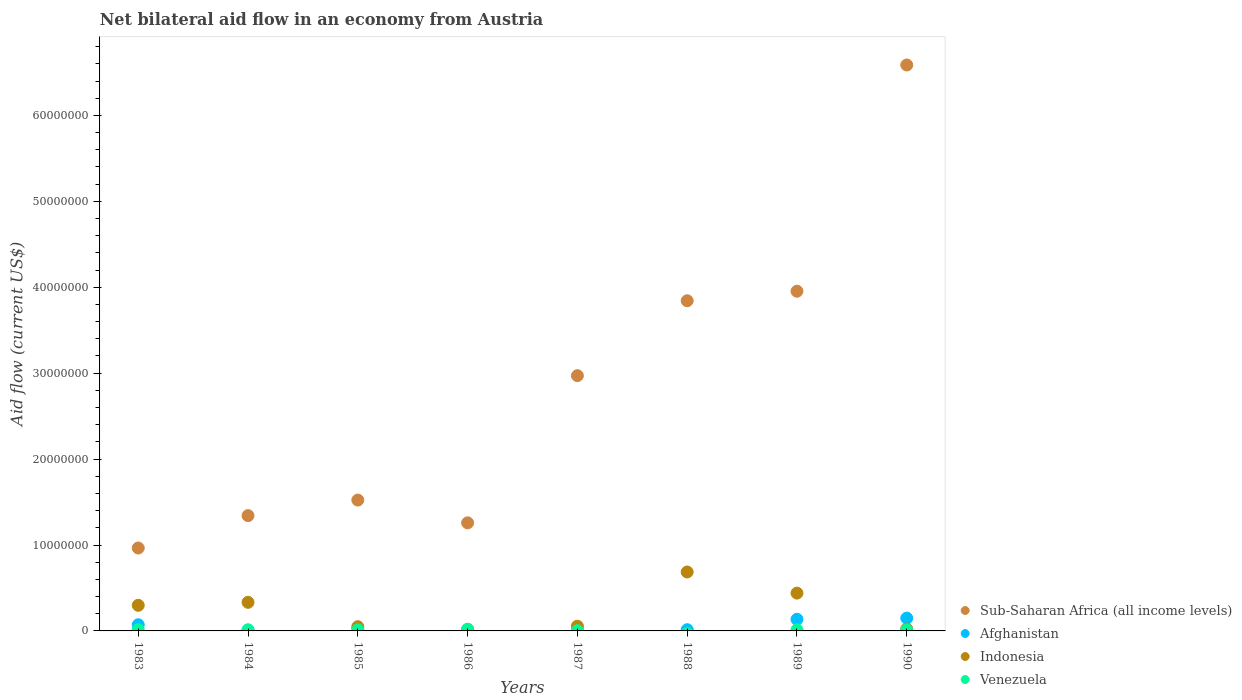How many different coloured dotlines are there?
Provide a succinct answer. 4. Across all years, what is the maximum net bilateral aid flow in Afghanistan?
Keep it short and to the point. 1.49e+06. Across all years, what is the minimum net bilateral aid flow in Sub-Saharan Africa (all income levels)?
Offer a very short reply. 9.65e+06. What is the total net bilateral aid flow in Venezuela in the graph?
Ensure brevity in your answer.  8.30e+05. What is the difference between the net bilateral aid flow in Indonesia in 1983 and that in 1987?
Give a very brief answer. 2.43e+06. What is the difference between the net bilateral aid flow in Afghanistan in 1984 and the net bilateral aid flow in Sub-Saharan Africa (all income levels) in 1983?
Offer a very short reply. -9.54e+06. What is the average net bilateral aid flow in Sub-Saharan Africa (all income levels) per year?
Your response must be concise. 2.81e+07. In the year 1989, what is the difference between the net bilateral aid flow in Sub-Saharan Africa (all income levels) and net bilateral aid flow in Venezuela?
Offer a terse response. 3.94e+07. What is the ratio of the net bilateral aid flow in Indonesia in 1986 to that in 1990?
Offer a very short reply. 0.83. What is the difference between the highest and the second highest net bilateral aid flow in Venezuela?
Your answer should be very brief. 2.00e+04. What is the difference between the highest and the lowest net bilateral aid flow in Afghanistan?
Give a very brief answer. 1.40e+06. In how many years, is the net bilateral aid flow in Venezuela greater than the average net bilateral aid flow in Venezuela taken over all years?
Your answer should be very brief. 6. Is the sum of the net bilateral aid flow in Venezuela in 1983 and 1987 greater than the maximum net bilateral aid flow in Indonesia across all years?
Make the answer very short. No. Is it the case that in every year, the sum of the net bilateral aid flow in Afghanistan and net bilateral aid flow in Indonesia  is greater than the sum of net bilateral aid flow in Sub-Saharan Africa (all income levels) and net bilateral aid flow in Venezuela?
Your answer should be very brief. Yes. Does the net bilateral aid flow in Afghanistan monotonically increase over the years?
Provide a succinct answer. No. Is the net bilateral aid flow in Afghanistan strictly greater than the net bilateral aid flow in Venezuela over the years?
Give a very brief answer. No. How many dotlines are there?
Offer a very short reply. 4. How many years are there in the graph?
Keep it short and to the point. 8. Are the values on the major ticks of Y-axis written in scientific E-notation?
Provide a succinct answer. No. Does the graph contain any zero values?
Provide a succinct answer. Yes. Does the graph contain grids?
Provide a short and direct response. No. How are the legend labels stacked?
Offer a very short reply. Vertical. What is the title of the graph?
Provide a short and direct response. Net bilateral aid flow in an economy from Austria. What is the label or title of the X-axis?
Make the answer very short. Years. What is the label or title of the Y-axis?
Provide a short and direct response. Aid flow (current US$). What is the Aid flow (current US$) of Sub-Saharan Africa (all income levels) in 1983?
Ensure brevity in your answer.  9.65e+06. What is the Aid flow (current US$) in Afghanistan in 1983?
Make the answer very short. 7.20e+05. What is the Aid flow (current US$) of Indonesia in 1983?
Give a very brief answer. 2.98e+06. What is the Aid flow (current US$) of Sub-Saharan Africa (all income levels) in 1984?
Ensure brevity in your answer.  1.34e+07. What is the Aid flow (current US$) in Afghanistan in 1984?
Your answer should be compact. 1.10e+05. What is the Aid flow (current US$) of Indonesia in 1984?
Provide a succinct answer. 3.33e+06. What is the Aid flow (current US$) in Venezuela in 1984?
Give a very brief answer. 1.10e+05. What is the Aid flow (current US$) in Sub-Saharan Africa (all income levels) in 1985?
Make the answer very short. 1.52e+07. What is the Aid flow (current US$) of Afghanistan in 1985?
Your answer should be very brief. 1.70e+05. What is the Aid flow (current US$) of Venezuela in 1985?
Provide a short and direct response. 1.20e+05. What is the Aid flow (current US$) in Sub-Saharan Africa (all income levels) in 1986?
Offer a terse response. 1.26e+07. What is the Aid flow (current US$) in Indonesia in 1986?
Your answer should be compact. 1.90e+05. What is the Aid flow (current US$) in Venezuela in 1986?
Your response must be concise. 1.70e+05. What is the Aid flow (current US$) in Sub-Saharan Africa (all income levels) in 1987?
Provide a short and direct response. 2.97e+07. What is the Aid flow (current US$) in Sub-Saharan Africa (all income levels) in 1988?
Offer a terse response. 3.84e+07. What is the Aid flow (current US$) of Indonesia in 1988?
Provide a succinct answer. 6.86e+06. What is the Aid flow (current US$) in Sub-Saharan Africa (all income levels) in 1989?
Give a very brief answer. 3.95e+07. What is the Aid flow (current US$) of Afghanistan in 1989?
Ensure brevity in your answer.  1.35e+06. What is the Aid flow (current US$) of Indonesia in 1989?
Provide a succinct answer. 4.40e+06. What is the Aid flow (current US$) in Sub-Saharan Africa (all income levels) in 1990?
Your answer should be very brief. 6.59e+07. What is the Aid flow (current US$) of Afghanistan in 1990?
Ensure brevity in your answer.  1.49e+06. What is the Aid flow (current US$) in Indonesia in 1990?
Ensure brevity in your answer.  2.30e+05. What is the Aid flow (current US$) of Venezuela in 1990?
Provide a succinct answer. 1.20e+05. Across all years, what is the maximum Aid flow (current US$) in Sub-Saharan Africa (all income levels)?
Offer a very short reply. 6.59e+07. Across all years, what is the maximum Aid flow (current US$) of Afghanistan?
Your answer should be very brief. 1.49e+06. Across all years, what is the maximum Aid flow (current US$) of Indonesia?
Your answer should be compact. 6.86e+06. Across all years, what is the maximum Aid flow (current US$) of Venezuela?
Give a very brief answer. 1.70e+05. Across all years, what is the minimum Aid flow (current US$) in Sub-Saharan Africa (all income levels)?
Your response must be concise. 9.65e+06. Across all years, what is the minimum Aid flow (current US$) in Afghanistan?
Offer a terse response. 9.00e+04. Across all years, what is the minimum Aid flow (current US$) of Indonesia?
Give a very brief answer. 1.90e+05. Across all years, what is the minimum Aid flow (current US$) of Venezuela?
Provide a succinct answer. 0. What is the total Aid flow (current US$) in Sub-Saharan Africa (all income levels) in the graph?
Keep it short and to the point. 2.24e+08. What is the total Aid flow (current US$) of Afghanistan in the graph?
Your response must be concise. 4.18e+06. What is the total Aid flow (current US$) in Indonesia in the graph?
Offer a very short reply. 1.90e+07. What is the total Aid flow (current US$) of Venezuela in the graph?
Make the answer very short. 8.30e+05. What is the difference between the Aid flow (current US$) in Sub-Saharan Africa (all income levels) in 1983 and that in 1984?
Your answer should be compact. -3.77e+06. What is the difference between the Aid flow (current US$) of Indonesia in 1983 and that in 1984?
Your answer should be compact. -3.50e+05. What is the difference between the Aid flow (current US$) of Venezuela in 1983 and that in 1984?
Offer a terse response. 4.00e+04. What is the difference between the Aid flow (current US$) in Sub-Saharan Africa (all income levels) in 1983 and that in 1985?
Ensure brevity in your answer.  -5.58e+06. What is the difference between the Aid flow (current US$) in Indonesia in 1983 and that in 1985?
Your response must be concise. 2.49e+06. What is the difference between the Aid flow (current US$) in Sub-Saharan Africa (all income levels) in 1983 and that in 1986?
Provide a succinct answer. -2.93e+06. What is the difference between the Aid flow (current US$) of Afghanistan in 1983 and that in 1986?
Keep it short and to the point. 6.30e+05. What is the difference between the Aid flow (current US$) of Indonesia in 1983 and that in 1986?
Your response must be concise. 2.79e+06. What is the difference between the Aid flow (current US$) of Sub-Saharan Africa (all income levels) in 1983 and that in 1987?
Your response must be concise. -2.01e+07. What is the difference between the Aid flow (current US$) of Indonesia in 1983 and that in 1987?
Your answer should be very brief. 2.43e+06. What is the difference between the Aid flow (current US$) in Sub-Saharan Africa (all income levels) in 1983 and that in 1988?
Your answer should be very brief. -2.88e+07. What is the difference between the Aid flow (current US$) in Afghanistan in 1983 and that in 1988?
Offer a terse response. 5.80e+05. What is the difference between the Aid flow (current US$) of Indonesia in 1983 and that in 1988?
Provide a succinct answer. -3.88e+06. What is the difference between the Aid flow (current US$) of Sub-Saharan Africa (all income levels) in 1983 and that in 1989?
Provide a short and direct response. -2.99e+07. What is the difference between the Aid flow (current US$) in Afghanistan in 1983 and that in 1989?
Provide a succinct answer. -6.30e+05. What is the difference between the Aid flow (current US$) of Indonesia in 1983 and that in 1989?
Provide a succinct answer. -1.42e+06. What is the difference between the Aid flow (current US$) in Venezuela in 1983 and that in 1989?
Keep it short and to the point. 2.00e+04. What is the difference between the Aid flow (current US$) in Sub-Saharan Africa (all income levels) in 1983 and that in 1990?
Offer a very short reply. -5.62e+07. What is the difference between the Aid flow (current US$) of Afghanistan in 1983 and that in 1990?
Your response must be concise. -7.70e+05. What is the difference between the Aid flow (current US$) in Indonesia in 1983 and that in 1990?
Offer a terse response. 2.75e+06. What is the difference between the Aid flow (current US$) in Venezuela in 1983 and that in 1990?
Offer a terse response. 3.00e+04. What is the difference between the Aid flow (current US$) in Sub-Saharan Africa (all income levels) in 1984 and that in 1985?
Your response must be concise. -1.81e+06. What is the difference between the Aid flow (current US$) in Indonesia in 1984 and that in 1985?
Provide a short and direct response. 2.84e+06. What is the difference between the Aid flow (current US$) in Sub-Saharan Africa (all income levels) in 1984 and that in 1986?
Offer a terse response. 8.40e+05. What is the difference between the Aid flow (current US$) of Indonesia in 1984 and that in 1986?
Your answer should be very brief. 3.14e+06. What is the difference between the Aid flow (current US$) of Venezuela in 1984 and that in 1986?
Give a very brief answer. -6.00e+04. What is the difference between the Aid flow (current US$) of Sub-Saharan Africa (all income levels) in 1984 and that in 1987?
Offer a very short reply. -1.63e+07. What is the difference between the Aid flow (current US$) of Afghanistan in 1984 and that in 1987?
Offer a terse response. 0. What is the difference between the Aid flow (current US$) in Indonesia in 1984 and that in 1987?
Provide a succinct answer. 2.78e+06. What is the difference between the Aid flow (current US$) in Venezuela in 1984 and that in 1987?
Make the answer very short. 8.00e+04. What is the difference between the Aid flow (current US$) of Sub-Saharan Africa (all income levels) in 1984 and that in 1988?
Your answer should be very brief. -2.50e+07. What is the difference between the Aid flow (current US$) in Afghanistan in 1984 and that in 1988?
Your answer should be compact. -3.00e+04. What is the difference between the Aid flow (current US$) in Indonesia in 1984 and that in 1988?
Make the answer very short. -3.53e+06. What is the difference between the Aid flow (current US$) in Sub-Saharan Africa (all income levels) in 1984 and that in 1989?
Ensure brevity in your answer.  -2.61e+07. What is the difference between the Aid flow (current US$) of Afghanistan in 1984 and that in 1989?
Keep it short and to the point. -1.24e+06. What is the difference between the Aid flow (current US$) of Indonesia in 1984 and that in 1989?
Give a very brief answer. -1.07e+06. What is the difference between the Aid flow (current US$) of Sub-Saharan Africa (all income levels) in 1984 and that in 1990?
Ensure brevity in your answer.  -5.24e+07. What is the difference between the Aid flow (current US$) of Afghanistan in 1984 and that in 1990?
Your answer should be very brief. -1.38e+06. What is the difference between the Aid flow (current US$) of Indonesia in 1984 and that in 1990?
Ensure brevity in your answer.  3.10e+06. What is the difference between the Aid flow (current US$) of Venezuela in 1984 and that in 1990?
Give a very brief answer. -10000. What is the difference between the Aid flow (current US$) in Sub-Saharan Africa (all income levels) in 1985 and that in 1986?
Provide a succinct answer. 2.65e+06. What is the difference between the Aid flow (current US$) in Afghanistan in 1985 and that in 1986?
Make the answer very short. 8.00e+04. What is the difference between the Aid flow (current US$) in Indonesia in 1985 and that in 1986?
Provide a short and direct response. 3.00e+05. What is the difference between the Aid flow (current US$) in Venezuela in 1985 and that in 1986?
Your answer should be compact. -5.00e+04. What is the difference between the Aid flow (current US$) of Sub-Saharan Africa (all income levels) in 1985 and that in 1987?
Ensure brevity in your answer.  -1.45e+07. What is the difference between the Aid flow (current US$) in Afghanistan in 1985 and that in 1987?
Provide a short and direct response. 6.00e+04. What is the difference between the Aid flow (current US$) of Indonesia in 1985 and that in 1987?
Keep it short and to the point. -6.00e+04. What is the difference between the Aid flow (current US$) of Venezuela in 1985 and that in 1987?
Make the answer very short. 9.00e+04. What is the difference between the Aid flow (current US$) of Sub-Saharan Africa (all income levels) in 1985 and that in 1988?
Provide a short and direct response. -2.32e+07. What is the difference between the Aid flow (current US$) of Afghanistan in 1985 and that in 1988?
Provide a short and direct response. 3.00e+04. What is the difference between the Aid flow (current US$) in Indonesia in 1985 and that in 1988?
Provide a short and direct response. -6.37e+06. What is the difference between the Aid flow (current US$) of Sub-Saharan Africa (all income levels) in 1985 and that in 1989?
Keep it short and to the point. -2.43e+07. What is the difference between the Aid flow (current US$) of Afghanistan in 1985 and that in 1989?
Your answer should be very brief. -1.18e+06. What is the difference between the Aid flow (current US$) in Indonesia in 1985 and that in 1989?
Give a very brief answer. -3.91e+06. What is the difference between the Aid flow (current US$) in Venezuela in 1985 and that in 1989?
Your answer should be compact. -10000. What is the difference between the Aid flow (current US$) of Sub-Saharan Africa (all income levels) in 1985 and that in 1990?
Ensure brevity in your answer.  -5.06e+07. What is the difference between the Aid flow (current US$) of Afghanistan in 1985 and that in 1990?
Keep it short and to the point. -1.32e+06. What is the difference between the Aid flow (current US$) of Sub-Saharan Africa (all income levels) in 1986 and that in 1987?
Offer a very short reply. -1.71e+07. What is the difference between the Aid flow (current US$) of Afghanistan in 1986 and that in 1987?
Offer a very short reply. -2.00e+04. What is the difference between the Aid flow (current US$) in Indonesia in 1986 and that in 1987?
Your response must be concise. -3.60e+05. What is the difference between the Aid flow (current US$) in Venezuela in 1986 and that in 1987?
Provide a succinct answer. 1.40e+05. What is the difference between the Aid flow (current US$) of Sub-Saharan Africa (all income levels) in 1986 and that in 1988?
Your answer should be very brief. -2.58e+07. What is the difference between the Aid flow (current US$) of Afghanistan in 1986 and that in 1988?
Offer a terse response. -5.00e+04. What is the difference between the Aid flow (current US$) of Indonesia in 1986 and that in 1988?
Provide a succinct answer. -6.67e+06. What is the difference between the Aid flow (current US$) of Sub-Saharan Africa (all income levels) in 1986 and that in 1989?
Provide a succinct answer. -2.70e+07. What is the difference between the Aid flow (current US$) in Afghanistan in 1986 and that in 1989?
Provide a succinct answer. -1.26e+06. What is the difference between the Aid flow (current US$) in Indonesia in 1986 and that in 1989?
Provide a short and direct response. -4.21e+06. What is the difference between the Aid flow (current US$) in Venezuela in 1986 and that in 1989?
Your answer should be compact. 4.00e+04. What is the difference between the Aid flow (current US$) in Sub-Saharan Africa (all income levels) in 1986 and that in 1990?
Provide a succinct answer. -5.33e+07. What is the difference between the Aid flow (current US$) of Afghanistan in 1986 and that in 1990?
Your answer should be compact. -1.40e+06. What is the difference between the Aid flow (current US$) of Indonesia in 1986 and that in 1990?
Your response must be concise. -4.00e+04. What is the difference between the Aid flow (current US$) in Venezuela in 1986 and that in 1990?
Provide a short and direct response. 5.00e+04. What is the difference between the Aid flow (current US$) of Sub-Saharan Africa (all income levels) in 1987 and that in 1988?
Offer a terse response. -8.72e+06. What is the difference between the Aid flow (current US$) of Afghanistan in 1987 and that in 1988?
Your answer should be very brief. -3.00e+04. What is the difference between the Aid flow (current US$) of Indonesia in 1987 and that in 1988?
Give a very brief answer. -6.31e+06. What is the difference between the Aid flow (current US$) of Sub-Saharan Africa (all income levels) in 1987 and that in 1989?
Your answer should be compact. -9.83e+06. What is the difference between the Aid flow (current US$) of Afghanistan in 1987 and that in 1989?
Make the answer very short. -1.24e+06. What is the difference between the Aid flow (current US$) of Indonesia in 1987 and that in 1989?
Ensure brevity in your answer.  -3.85e+06. What is the difference between the Aid flow (current US$) in Venezuela in 1987 and that in 1989?
Your answer should be compact. -1.00e+05. What is the difference between the Aid flow (current US$) of Sub-Saharan Africa (all income levels) in 1987 and that in 1990?
Keep it short and to the point. -3.62e+07. What is the difference between the Aid flow (current US$) in Afghanistan in 1987 and that in 1990?
Your answer should be very brief. -1.38e+06. What is the difference between the Aid flow (current US$) of Sub-Saharan Africa (all income levels) in 1988 and that in 1989?
Your answer should be compact. -1.11e+06. What is the difference between the Aid flow (current US$) in Afghanistan in 1988 and that in 1989?
Provide a succinct answer. -1.21e+06. What is the difference between the Aid flow (current US$) of Indonesia in 1988 and that in 1989?
Your answer should be very brief. 2.46e+06. What is the difference between the Aid flow (current US$) of Sub-Saharan Africa (all income levels) in 1988 and that in 1990?
Make the answer very short. -2.74e+07. What is the difference between the Aid flow (current US$) of Afghanistan in 1988 and that in 1990?
Provide a succinct answer. -1.35e+06. What is the difference between the Aid flow (current US$) in Indonesia in 1988 and that in 1990?
Keep it short and to the point. 6.63e+06. What is the difference between the Aid flow (current US$) in Sub-Saharan Africa (all income levels) in 1989 and that in 1990?
Offer a very short reply. -2.63e+07. What is the difference between the Aid flow (current US$) of Afghanistan in 1989 and that in 1990?
Provide a short and direct response. -1.40e+05. What is the difference between the Aid flow (current US$) of Indonesia in 1989 and that in 1990?
Provide a short and direct response. 4.17e+06. What is the difference between the Aid flow (current US$) of Sub-Saharan Africa (all income levels) in 1983 and the Aid flow (current US$) of Afghanistan in 1984?
Your answer should be very brief. 9.54e+06. What is the difference between the Aid flow (current US$) in Sub-Saharan Africa (all income levels) in 1983 and the Aid flow (current US$) in Indonesia in 1984?
Keep it short and to the point. 6.32e+06. What is the difference between the Aid flow (current US$) of Sub-Saharan Africa (all income levels) in 1983 and the Aid flow (current US$) of Venezuela in 1984?
Make the answer very short. 9.54e+06. What is the difference between the Aid flow (current US$) of Afghanistan in 1983 and the Aid flow (current US$) of Indonesia in 1984?
Offer a terse response. -2.61e+06. What is the difference between the Aid flow (current US$) in Afghanistan in 1983 and the Aid flow (current US$) in Venezuela in 1984?
Make the answer very short. 6.10e+05. What is the difference between the Aid flow (current US$) of Indonesia in 1983 and the Aid flow (current US$) of Venezuela in 1984?
Your answer should be compact. 2.87e+06. What is the difference between the Aid flow (current US$) in Sub-Saharan Africa (all income levels) in 1983 and the Aid flow (current US$) in Afghanistan in 1985?
Your answer should be compact. 9.48e+06. What is the difference between the Aid flow (current US$) in Sub-Saharan Africa (all income levels) in 1983 and the Aid flow (current US$) in Indonesia in 1985?
Offer a very short reply. 9.16e+06. What is the difference between the Aid flow (current US$) of Sub-Saharan Africa (all income levels) in 1983 and the Aid flow (current US$) of Venezuela in 1985?
Offer a very short reply. 9.53e+06. What is the difference between the Aid flow (current US$) in Afghanistan in 1983 and the Aid flow (current US$) in Indonesia in 1985?
Provide a short and direct response. 2.30e+05. What is the difference between the Aid flow (current US$) in Afghanistan in 1983 and the Aid flow (current US$) in Venezuela in 1985?
Give a very brief answer. 6.00e+05. What is the difference between the Aid flow (current US$) of Indonesia in 1983 and the Aid flow (current US$) of Venezuela in 1985?
Make the answer very short. 2.86e+06. What is the difference between the Aid flow (current US$) of Sub-Saharan Africa (all income levels) in 1983 and the Aid flow (current US$) of Afghanistan in 1986?
Provide a short and direct response. 9.56e+06. What is the difference between the Aid flow (current US$) in Sub-Saharan Africa (all income levels) in 1983 and the Aid flow (current US$) in Indonesia in 1986?
Ensure brevity in your answer.  9.46e+06. What is the difference between the Aid flow (current US$) of Sub-Saharan Africa (all income levels) in 1983 and the Aid flow (current US$) of Venezuela in 1986?
Provide a short and direct response. 9.48e+06. What is the difference between the Aid flow (current US$) in Afghanistan in 1983 and the Aid flow (current US$) in Indonesia in 1986?
Your response must be concise. 5.30e+05. What is the difference between the Aid flow (current US$) of Indonesia in 1983 and the Aid flow (current US$) of Venezuela in 1986?
Offer a terse response. 2.81e+06. What is the difference between the Aid flow (current US$) of Sub-Saharan Africa (all income levels) in 1983 and the Aid flow (current US$) of Afghanistan in 1987?
Provide a succinct answer. 9.54e+06. What is the difference between the Aid flow (current US$) of Sub-Saharan Africa (all income levels) in 1983 and the Aid flow (current US$) of Indonesia in 1987?
Ensure brevity in your answer.  9.10e+06. What is the difference between the Aid flow (current US$) in Sub-Saharan Africa (all income levels) in 1983 and the Aid flow (current US$) in Venezuela in 1987?
Ensure brevity in your answer.  9.62e+06. What is the difference between the Aid flow (current US$) of Afghanistan in 1983 and the Aid flow (current US$) of Indonesia in 1987?
Give a very brief answer. 1.70e+05. What is the difference between the Aid flow (current US$) in Afghanistan in 1983 and the Aid flow (current US$) in Venezuela in 1987?
Give a very brief answer. 6.90e+05. What is the difference between the Aid flow (current US$) in Indonesia in 1983 and the Aid flow (current US$) in Venezuela in 1987?
Your response must be concise. 2.95e+06. What is the difference between the Aid flow (current US$) in Sub-Saharan Africa (all income levels) in 1983 and the Aid flow (current US$) in Afghanistan in 1988?
Keep it short and to the point. 9.51e+06. What is the difference between the Aid flow (current US$) in Sub-Saharan Africa (all income levels) in 1983 and the Aid flow (current US$) in Indonesia in 1988?
Your answer should be compact. 2.79e+06. What is the difference between the Aid flow (current US$) of Afghanistan in 1983 and the Aid flow (current US$) of Indonesia in 1988?
Keep it short and to the point. -6.14e+06. What is the difference between the Aid flow (current US$) of Sub-Saharan Africa (all income levels) in 1983 and the Aid flow (current US$) of Afghanistan in 1989?
Ensure brevity in your answer.  8.30e+06. What is the difference between the Aid flow (current US$) in Sub-Saharan Africa (all income levels) in 1983 and the Aid flow (current US$) in Indonesia in 1989?
Keep it short and to the point. 5.25e+06. What is the difference between the Aid flow (current US$) in Sub-Saharan Africa (all income levels) in 1983 and the Aid flow (current US$) in Venezuela in 1989?
Offer a very short reply. 9.52e+06. What is the difference between the Aid flow (current US$) in Afghanistan in 1983 and the Aid flow (current US$) in Indonesia in 1989?
Ensure brevity in your answer.  -3.68e+06. What is the difference between the Aid flow (current US$) in Afghanistan in 1983 and the Aid flow (current US$) in Venezuela in 1989?
Your answer should be very brief. 5.90e+05. What is the difference between the Aid flow (current US$) in Indonesia in 1983 and the Aid flow (current US$) in Venezuela in 1989?
Your response must be concise. 2.85e+06. What is the difference between the Aid flow (current US$) in Sub-Saharan Africa (all income levels) in 1983 and the Aid flow (current US$) in Afghanistan in 1990?
Ensure brevity in your answer.  8.16e+06. What is the difference between the Aid flow (current US$) of Sub-Saharan Africa (all income levels) in 1983 and the Aid flow (current US$) of Indonesia in 1990?
Provide a succinct answer. 9.42e+06. What is the difference between the Aid flow (current US$) of Sub-Saharan Africa (all income levels) in 1983 and the Aid flow (current US$) of Venezuela in 1990?
Offer a very short reply. 9.53e+06. What is the difference between the Aid flow (current US$) in Afghanistan in 1983 and the Aid flow (current US$) in Venezuela in 1990?
Ensure brevity in your answer.  6.00e+05. What is the difference between the Aid flow (current US$) in Indonesia in 1983 and the Aid flow (current US$) in Venezuela in 1990?
Provide a short and direct response. 2.86e+06. What is the difference between the Aid flow (current US$) of Sub-Saharan Africa (all income levels) in 1984 and the Aid flow (current US$) of Afghanistan in 1985?
Provide a short and direct response. 1.32e+07. What is the difference between the Aid flow (current US$) of Sub-Saharan Africa (all income levels) in 1984 and the Aid flow (current US$) of Indonesia in 1985?
Provide a succinct answer. 1.29e+07. What is the difference between the Aid flow (current US$) in Sub-Saharan Africa (all income levels) in 1984 and the Aid flow (current US$) in Venezuela in 1985?
Provide a succinct answer. 1.33e+07. What is the difference between the Aid flow (current US$) of Afghanistan in 1984 and the Aid flow (current US$) of Indonesia in 1985?
Ensure brevity in your answer.  -3.80e+05. What is the difference between the Aid flow (current US$) in Afghanistan in 1984 and the Aid flow (current US$) in Venezuela in 1985?
Provide a succinct answer. -10000. What is the difference between the Aid flow (current US$) of Indonesia in 1984 and the Aid flow (current US$) of Venezuela in 1985?
Make the answer very short. 3.21e+06. What is the difference between the Aid flow (current US$) in Sub-Saharan Africa (all income levels) in 1984 and the Aid flow (current US$) in Afghanistan in 1986?
Provide a succinct answer. 1.33e+07. What is the difference between the Aid flow (current US$) in Sub-Saharan Africa (all income levels) in 1984 and the Aid flow (current US$) in Indonesia in 1986?
Your answer should be very brief. 1.32e+07. What is the difference between the Aid flow (current US$) of Sub-Saharan Africa (all income levels) in 1984 and the Aid flow (current US$) of Venezuela in 1986?
Provide a succinct answer. 1.32e+07. What is the difference between the Aid flow (current US$) in Indonesia in 1984 and the Aid flow (current US$) in Venezuela in 1986?
Your response must be concise. 3.16e+06. What is the difference between the Aid flow (current US$) of Sub-Saharan Africa (all income levels) in 1984 and the Aid flow (current US$) of Afghanistan in 1987?
Ensure brevity in your answer.  1.33e+07. What is the difference between the Aid flow (current US$) of Sub-Saharan Africa (all income levels) in 1984 and the Aid flow (current US$) of Indonesia in 1987?
Your answer should be very brief. 1.29e+07. What is the difference between the Aid flow (current US$) in Sub-Saharan Africa (all income levels) in 1984 and the Aid flow (current US$) in Venezuela in 1987?
Make the answer very short. 1.34e+07. What is the difference between the Aid flow (current US$) of Afghanistan in 1984 and the Aid flow (current US$) of Indonesia in 1987?
Your answer should be very brief. -4.40e+05. What is the difference between the Aid flow (current US$) of Indonesia in 1984 and the Aid flow (current US$) of Venezuela in 1987?
Your response must be concise. 3.30e+06. What is the difference between the Aid flow (current US$) in Sub-Saharan Africa (all income levels) in 1984 and the Aid flow (current US$) in Afghanistan in 1988?
Keep it short and to the point. 1.33e+07. What is the difference between the Aid flow (current US$) of Sub-Saharan Africa (all income levels) in 1984 and the Aid flow (current US$) of Indonesia in 1988?
Keep it short and to the point. 6.56e+06. What is the difference between the Aid flow (current US$) in Afghanistan in 1984 and the Aid flow (current US$) in Indonesia in 1988?
Offer a very short reply. -6.75e+06. What is the difference between the Aid flow (current US$) in Sub-Saharan Africa (all income levels) in 1984 and the Aid flow (current US$) in Afghanistan in 1989?
Give a very brief answer. 1.21e+07. What is the difference between the Aid flow (current US$) of Sub-Saharan Africa (all income levels) in 1984 and the Aid flow (current US$) of Indonesia in 1989?
Ensure brevity in your answer.  9.02e+06. What is the difference between the Aid flow (current US$) of Sub-Saharan Africa (all income levels) in 1984 and the Aid flow (current US$) of Venezuela in 1989?
Keep it short and to the point. 1.33e+07. What is the difference between the Aid flow (current US$) of Afghanistan in 1984 and the Aid flow (current US$) of Indonesia in 1989?
Offer a very short reply. -4.29e+06. What is the difference between the Aid flow (current US$) of Indonesia in 1984 and the Aid flow (current US$) of Venezuela in 1989?
Provide a succinct answer. 3.20e+06. What is the difference between the Aid flow (current US$) of Sub-Saharan Africa (all income levels) in 1984 and the Aid flow (current US$) of Afghanistan in 1990?
Your answer should be compact. 1.19e+07. What is the difference between the Aid flow (current US$) of Sub-Saharan Africa (all income levels) in 1984 and the Aid flow (current US$) of Indonesia in 1990?
Provide a succinct answer. 1.32e+07. What is the difference between the Aid flow (current US$) in Sub-Saharan Africa (all income levels) in 1984 and the Aid flow (current US$) in Venezuela in 1990?
Provide a succinct answer. 1.33e+07. What is the difference between the Aid flow (current US$) in Afghanistan in 1984 and the Aid flow (current US$) in Venezuela in 1990?
Make the answer very short. -10000. What is the difference between the Aid flow (current US$) in Indonesia in 1984 and the Aid flow (current US$) in Venezuela in 1990?
Ensure brevity in your answer.  3.21e+06. What is the difference between the Aid flow (current US$) in Sub-Saharan Africa (all income levels) in 1985 and the Aid flow (current US$) in Afghanistan in 1986?
Keep it short and to the point. 1.51e+07. What is the difference between the Aid flow (current US$) of Sub-Saharan Africa (all income levels) in 1985 and the Aid flow (current US$) of Indonesia in 1986?
Provide a short and direct response. 1.50e+07. What is the difference between the Aid flow (current US$) in Sub-Saharan Africa (all income levels) in 1985 and the Aid flow (current US$) in Venezuela in 1986?
Your answer should be compact. 1.51e+07. What is the difference between the Aid flow (current US$) of Afghanistan in 1985 and the Aid flow (current US$) of Indonesia in 1986?
Your answer should be very brief. -2.00e+04. What is the difference between the Aid flow (current US$) in Sub-Saharan Africa (all income levels) in 1985 and the Aid flow (current US$) in Afghanistan in 1987?
Give a very brief answer. 1.51e+07. What is the difference between the Aid flow (current US$) in Sub-Saharan Africa (all income levels) in 1985 and the Aid flow (current US$) in Indonesia in 1987?
Offer a terse response. 1.47e+07. What is the difference between the Aid flow (current US$) of Sub-Saharan Africa (all income levels) in 1985 and the Aid flow (current US$) of Venezuela in 1987?
Your answer should be compact. 1.52e+07. What is the difference between the Aid flow (current US$) in Afghanistan in 1985 and the Aid flow (current US$) in Indonesia in 1987?
Your answer should be very brief. -3.80e+05. What is the difference between the Aid flow (current US$) of Indonesia in 1985 and the Aid flow (current US$) of Venezuela in 1987?
Make the answer very short. 4.60e+05. What is the difference between the Aid flow (current US$) in Sub-Saharan Africa (all income levels) in 1985 and the Aid flow (current US$) in Afghanistan in 1988?
Make the answer very short. 1.51e+07. What is the difference between the Aid flow (current US$) in Sub-Saharan Africa (all income levels) in 1985 and the Aid flow (current US$) in Indonesia in 1988?
Offer a terse response. 8.37e+06. What is the difference between the Aid flow (current US$) of Afghanistan in 1985 and the Aid flow (current US$) of Indonesia in 1988?
Keep it short and to the point. -6.69e+06. What is the difference between the Aid flow (current US$) in Sub-Saharan Africa (all income levels) in 1985 and the Aid flow (current US$) in Afghanistan in 1989?
Ensure brevity in your answer.  1.39e+07. What is the difference between the Aid flow (current US$) of Sub-Saharan Africa (all income levels) in 1985 and the Aid flow (current US$) of Indonesia in 1989?
Provide a succinct answer. 1.08e+07. What is the difference between the Aid flow (current US$) of Sub-Saharan Africa (all income levels) in 1985 and the Aid flow (current US$) of Venezuela in 1989?
Your answer should be very brief. 1.51e+07. What is the difference between the Aid flow (current US$) of Afghanistan in 1985 and the Aid flow (current US$) of Indonesia in 1989?
Your answer should be compact. -4.23e+06. What is the difference between the Aid flow (current US$) of Afghanistan in 1985 and the Aid flow (current US$) of Venezuela in 1989?
Provide a short and direct response. 4.00e+04. What is the difference between the Aid flow (current US$) of Sub-Saharan Africa (all income levels) in 1985 and the Aid flow (current US$) of Afghanistan in 1990?
Offer a very short reply. 1.37e+07. What is the difference between the Aid flow (current US$) in Sub-Saharan Africa (all income levels) in 1985 and the Aid flow (current US$) in Indonesia in 1990?
Make the answer very short. 1.50e+07. What is the difference between the Aid flow (current US$) of Sub-Saharan Africa (all income levels) in 1985 and the Aid flow (current US$) of Venezuela in 1990?
Offer a very short reply. 1.51e+07. What is the difference between the Aid flow (current US$) of Sub-Saharan Africa (all income levels) in 1986 and the Aid flow (current US$) of Afghanistan in 1987?
Provide a succinct answer. 1.25e+07. What is the difference between the Aid flow (current US$) of Sub-Saharan Africa (all income levels) in 1986 and the Aid flow (current US$) of Indonesia in 1987?
Offer a very short reply. 1.20e+07. What is the difference between the Aid flow (current US$) of Sub-Saharan Africa (all income levels) in 1986 and the Aid flow (current US$) of Venezuela in 1987?
Offer a very short reply. 1.26e+07. What is the difference between the Aid flow (current US$) of Afghanistan in 1986 and the Aid flow (current US$) of Indonesia in 1987?
Your answer should be very brief. -4.60e+05. What is the difference between the Aid flow (current US$) of Afghanistan in 1986 and the Aid flow (current US$) of Venezuela in 1987?
Give a very brief answer. 6.00e+04. What is the difference between the Aid flow (current US$) in Sub-Saharan Africa (all income levels) in 1986 and the Aid flow (current US$) in Afghanistan in 1988?
Provide a succinct answer. 1.24e+07. What is the difference between the Aid flow (current US$) in Sub-Saharan Africa (all income levels) in 1986 and the Aid flow (current US$) in Indonesia in 1988?
Keep it short and to the point. 5.72e+06. What is the difference between the Aid flow (current US$) of Afghanistan in 1986 and the Aid flow (current US$) of Indonesia in 1988?
Give a very brief answer. -6.77e+06. What is the difference between the Aid flow (current US$) in Sub-Saharan Africa (all income levels) in 1986 and the Aid flow (current US$) in Afghanistan in 1989?
Provide a succinct answer. 1.12e+07. What is the difference between the Aid flow (current US$) of Sub-Saharan Africa (all income levels) in 1986 and the Aid flow (current US$) of Indonesia in 1989?
Ensure brevity in your answer.  8.18e+06. What is the difference between the Aid flow (current US$) of Sub-Saharan Africa (all income levels) in 1986 and the Aid flow (current US$) of Venezuela in 1989?
Offer a terse response. 1.24e+07. What is the difference between the Aid flow (current US$) in Afghanistan in 1986 and the Aid flow (current US$) in Indonesia in 1989?
Make the answer very short. -4.31e+06. What is the difference between the Aid flow (current US$) in Afghanistan in 1986 and the Aid flow (current US$) in Venezuela in 1989?
Your answer should be compact. -4.00e+04. What is the difference between the Aid flow (current US$) of Sub-Saharan Africa (all income levels) in 1986 and the Aid flow (current US$) of Afghanistan in 1990?
Your answer should be very brief. 1.11e+07. What is the difference between the Aid flow (current US$) of Sub-Saharan Africa (all income levels) in 1986 and the Aid flow (current US$) of Indonesia in 1990?
Give a very brief answer. 1.24e+07. What is the difference between the Aid flow (current US$) in Sub-Saharan Africa (all income levels) in 1986 and the Aid flow (current US$) in Venezuela in 1990?
Provide a short and direct response. 1.25e+07. What is the difference between the Aid flow (current US$) in Afghanistan in 1986 and the Aid flow (current US$) in Indonesia in 1990?
Keep it short and to the point. -1.40e+05. What is the difference between the Aid flow (current US$) in Afghanistan in 1986 and the Aid flow (current US$) in Venezuela in 1990?
Provide a succinct answer. -3.00e+04. What is the difference between the Aid flow (current US$) of Indonesia in 1986 and the Aid flow (current US$) of Venezuela in 1990?
Keep it short and to the point. 7.00e+04. What is the difference between the Aid flow (current US$) of Sub-Saharan Africa (all income levels) in 1987 and the Aid flow (current US$) of Afghanistan in 1988?
Provide a succinct answer. 2.96e+07. What is the difference between the Aid flow (current US$) of Sub-Saharan Africa (all income levels) in 1987 and the Aid flow (current US$) of Indonesia in 1988?
Your answer should be compact. 2.28e+07. What is the difference between the Aid flow (current US$) of Afghanistan in 1987 and the Aid flow (current US$) of Indonesia in 1988?
Your answer should be very brief. -6.75e+06. What is the difference between the Aid flow (current US$) in Sub-Saharan Africa (all income levels) in 1987 and the Aid flow (current US$) in Afghanistan in 1989?
Provide a succinct answer. 2.84e+07. What is the difference between the Aid flow (current US$) in Sub-Saharan Africa (all income levels) in 1987 and the Aid flow (current US$) in Indonesia in 1989?
Your response must be concise. 2.53e+07. What is the difference between the Aid flow (current US$) of Sub-Saharan Africa (all income levels) in 1987 and the Aid flow (current US$) of Venezuela in 1989?
Offer a terse response. 2.96e+07. What is the difference between the Aid flow (current US$) of Afghanistan in 1987 and the Aid flow (current US$) of Indonesia in 1989?
Offer a terse response. -4.29e+06. What is the difference between the Aid flow (current US$) in Sub-Saharan Africa (all income levels) in 1987 and the Aid flow (current US$) in Afghanistan in 1990?
Your response must be concise. 2.82e+07. What is the difference between the Aid flow (current US$) in Sub-Saharan Africa (all income levels) in 1987 and the Aid flow (current US$) in Indonesia in 1990?
Provide a short and direct response. 2.95e+07. What is the difference between the Aid flow (current US$) of Sub-Saharan Africa (all income levels) in 1987 and the Aid flow (current US$) of Venezuela in 1990?
Keep it short and to the point. 2.96e+07. What is the difference between the Aid flow (current US$) in Afghanistan in 1987 and the Aid flow (current US$) in Indonesia in 1990?
Keep it short and to the point. -1.20e+05. What is the difference between the Aid flow (current US$) in Afghanistan in 1987 and the Aid flow (current US$) in Venezuela in 1990?
Keep it short and to the point. -10000. What is the difference between the Aid flow (current US$) of Indonesia in 1987 and the Aid flow (current US$) of Venezuela in 1990?
Offer a very short reply. 4.30e+05. What is the difference between the Aid flow (current US$) in Sub-Saharan Africa (all income levels) in 1988 and the Aid flow (current US$) in Afghanistan in 1989?
Offer a very short reply. 3.71e+07. What is the difference between the Aid flow (current US$) of Sub-Saharan Africa (all income levels) in 1988 and the Aid flow (current US$) of Indonesia in 1989?
Provide a short and direct response. 3.40e+07. What is the difference between the Aid flow (current US$) of Sub-Saharan Africa (all income levels) in 1988 and the Aid flow (current US$) of Venezuela in 1989?
Your response must be concise. 3.83e+07. What is the difference between the Aid flow (current US$) in Afghanistan in 1988 and the Aid flow (current US$) in Indonesia in 1989?
Keep it short and to the point. -4.26e+06. What is the difference between the Aid flow (current US$) of Afghanistan in 1988 and the Aid flow (current US$) of Venezuela in 1989?
Offer a very short reply. 10000. What is the difference between the Aid flow (current US$) in Indonesia in 1988 and the Aid flow (current US$) in Venezuela in 1989?
Your answer should be compact. 6.73e+06. What is the difference between the Aid flow (current US$) in Sub-Saharan Africa (all income levels) in 1988 and the Aid flow (current US$) in Afghanistan in 1990?
Offer a very short reply. 3.69e+07. What is the difference between the Aid flow (current US$) of Sub-Saharan Africa (all income levels) in 1988 and the Aid flow (current US$) of Indonesia in 1990?
Your answer should be compact. 3.82e+07. What is the difference between the Aid flow (current US$) of Sub-Saharan Africa (all income levels) in 1988 and the Aid flow (current US$) of Venezuela in 1990?
Keep it short and to the point. 3.83e+07. What is the difference between the Aid flow (current US$) of Afghanistan in 1988 and the Aid flow (current US$) of Indonesia in 1990?
Keep it short and to the point. -9.00e+04. What is the difference between the Aid flow (current US$) in Afghanistan in 1988 and the Aid flow (current US$) in Venezuela in 1990?
Give a very brief answer. 2.00e+04. What is the difference between the Aid flow (current US$) of Indonesia in 1988 and the Aid flow (current US$) of Venezuela in 1990?
Your answer should be compact. 6.74e+06. What is the difference between the Aid flow (current US$) in Sub-Saharan Africa (all income levels) in 1989 and the Aid flow (current US$) in Afghanistan in 1990?
Provide a succinct answer. 3.80e+07. What is the difference between the Aid flow (current US$) in Sub-Saharan Africa (all income levels) in 1989 and the Aid flow (current US$) in Indonesia in 1990?
Ensure brevity in your answer.  3.93e+07. What is the difference between the Aid flow (current US$) in Sub-Saharan Africa (all income levels) in 1989 and the Aid flow (current US$) in Venezuela in 1990?
Make the answer very short. 3.94e+07. What is the difference between the Aid flow (current US$) of Afghanistan in 1989 and the Aid flow (current US$) of Indonesia in 1990?
Make the answer very short. 1.12e+06. What is the difference between the Aid flow (current US$) of Afghanistan in 1989 and the Aid flow (current US$) of Venezuela in 1990?
Your answer should be compact. 1.23e+06. What is the difference between the Aid flow (current US$) of Indonesia in 1989 and the Aid flow (current US$) of Venezuela in 1990?
Provide a succinct answer. 4.28e+06. What is the average Aid flow (current US$) in Sub-Saharan Africa (all income levels) per year?
Your response must be concise. 2.81e+07. What is the average Aid flow (current US$) in Afghanistan per year?
Keep it short and to the point. 5.22e+05. What is the average Aid flow (current US$) in Indonesia per year?
Provide a short and direct response. 2.38e+06. What is the average Aid flow (current US$) of Venezuela per year?
Provide a short and direct response. 1.04e+05. In the year 1983, what is the difference between the Aid flow (current US$) in Sub-Saharan Africa (all income levels) and Aid flow (current US$) in Afghanistan?
Offer a very short reply. 8.93e+06. In the year 1983, what is the difference between the Aid flow (current US$) in Sub-Saharan Africa (all income levels) and Aid flow (current US$) in Indonesia?
Offer a very short reply. 6.67e+06. In the year 1983, what is the difference between the Aid flow (current US$) in Sub-Saharan Africa (all income levels) and Aid flow (current US$) in Venezuela?
Keep it short and to the point. 9.50e+06. In the year 1983, what is the difference between the Aid flow (current US$) in Afghanistan and Aid flow (current US$) in Indonesia?
Offer a very short reply. -2.26e+06. In the year 1983, what is the difference between the Aid flow (current US$) of Afghanistan and Aid flow (current US$) of Venezuela?
Keep it short and to the point. 5.70e+05. In the year 1983, what is the difference between the Aid flow (current US$) in Indonesia and Aid flow (current US$) in Venezuela?
Your response must be concise. 2.83e+06. In the year 1984, what is the difference between the Aid flow (current US$) in Sub-Saharan Africa (all income levels) and Aid flow (current US$) in Afghanistan?
Provide a short and direct response. 1.33e+07. In the year 1984, what is the difference between the Aid flow (current US$) of Sub-Saharan Africa (all income levels) and Aid flow (current US$) of Indonesia?
Provide a succinct answer. 1.01e+07. In the year 1984, what is the difference between the Aid flow (current US$) of Sub-Saharan Africa (all income levels) and Aid flow (current US$) of Venezuela?
Keep it short and to the point. 1.33e+07. In the year 1984, what is the difference between the Aid flow (current US$) in Afghanistan and Aid flow (current US$) in Indonesia?
Offer a very short reply. -3.22e+06. In the year 1984, what is the difference between the Aid flow (current US$) of Afghanistan and Aid flow (current US$) of Venezuela?
Your answer should be compact. 0. In the year 1984, what is the difference between the Aid flow (current US$) of Indonesia and Aid flow (current US$) of Venezuela?
Provide a succinct answer. 3.22e+06. In the year 1985, what is the difference between the Aid flow (current US$) of Sub-Saharan Africa (all income levels) and Aid flow (current US$) of Afghanistan?
Your response must be concise. 1.51e+07. In the year 1985, what is the difference between the Aid flow (current US$) in Sub-Saharan Africa (all income levels) and Aid flow (current US$) in Indonesia?
Your answer should be very brief. 1.47e+07. In the year 1985, what is the difference between the Aid flow (current US$) in Sub-Saharan Africa (all income levels) and Aid flow (current US$) in Venezuela?
Provide a succinct answer. 1.51e+07. In the year 1985, what is the difference between the Aid flow (current US$) of Afghanistan and Aid flow (current US$) of Indonesia?
Your response must be concise. -3.20e+05. In the year 1986, what is the difference between the Aid flow (current US$) in Sub-Saharan Africa (all income levels) and Aid flow (current US$) in Afghanistan?
Offer a very short reply. 1.25e+07. In the year 1986, what is the difference between the Aid flow (current US$) of Sub-Saharan Africa (all income levels) and Aid flow (current US$) of Indonesia?
Ensure brevity in your answer.  1.24e+07. In the year 1986, what is the difference between the Aid flow (current US$) of Sub-Saharan Africa (all income levels) and Aid flow (current US$) of Venezuela?
Your answer should be compact. 1.24e+07. In the year 1986, what is the difference between the Aid flow (current US$) in Indonesia and Aid flow (current US$) in Venezuela?
Offer a very short reply. 2.00e+04. In the year 1987, what is the difference between the Aid flow (current US$) in Sub-Saharan Africa (all income levels) and Aid flow (current US$) in Afghanistan?
Offer a terse response. 2.96e+07. In the year 1987, what is the difference between the Aid flow (current US$) of Sub-Saharan Africa (all income levels) and Aid flow (current US$) of Indonesia?
Your answer should be very brief. 2.92e+07. In the year 1987, what is the difference between the Aid flow (current US$) of Sub-Saharan Africa (all income levels) and Aid flow (current US$) of Venezuela?
Give a very brief answer. 2.97e+07. In the year 1987, what is the difference between the Aid flow (current US$) in Afghanistan and Aid flow (current US$) in Indonesia?
Your answer should be compact. -4.40e+05. In the year 1987, what is the difference between the Aid flow (current US$) in Afghanistan and Aid flow (current US$) in Venezuela?
Your response must be concise. 8.00e+04. In the year 1987, what is the difference between the Aid flow (current US$) in Indonesia and Aid flow (current US$) in Venezuela?
Make the answer very short. 5.20e+05. In the year 1988, what is the difference between the Aid flow (current US$) of Sub-Saharan Africa (all income levels) and Aid flow (current US$) of Afghanistan?
Offer a very short reply. 3.83e+07. In the year 1988, what is the difference between the Aid flow (current US$) of Sub-Saharan Africa (all income levels) and Aid flow (current US$) of Indonesia?
Your answer should be very brief. 3.16e+07. In the year 1988, what is the difference between the Aid flow (current US$) in Afghanistan and Aid flow (current US$) in Indonesia?
Provide a short and direct response. -6.72e+06. In the year 1989, what is the difference between the Aid flow (current US$) of Sub-Saharan Africa (all income levels) and Aid flow (current US$) of Afghanistan?
Provide a succinct answer. 3.82e+07. In the year 1989, what is the difference between the Aid flow (current US$) of Sub-Saharan Africa (all income levels) and Aid flow (current US$) of Indonesia?
Your answer should be very brief. 3.51e+07. In the year 1989, what is the difference between the Aid flow (current US$) in Sub-Saharan Africa (all income levels) and Aid flow (current US$) in Venezuela?
Make the answer very short. 3.94e+07. In the year 1989, what is the difference between the Aid flow (current US$) of Afghanistan and Aid flow (current US$) of Indonesia?
Keep it short and to the point. -3.05e+06. In the year 1989, what is the difference between the Aid flow (current US$) of Afghanistan and Aid flow (current US$) of Venezuela?
Your answer should be very brief. 1.22e+06. In the year 1989, what is the difference between the Aid flow (current US$) in Indonesia and Aid flow (current US$) in Venezuela?
Your answer should be compact. 4.27e+06. In the year 1990, what is the difference between the Aid flow (current US$) of Sub-Saharan Africa (all income levels) and Aid flow (current US$) of Afghanistan?
Ensure brevity in your answer.  6.44e+07. In the year 1990, what is the difference between the Aid flow (current US$) in Sub-Saharan Africa (all income levels) and Aid flow (current US$) in Indonesia?
Provide a succinct answer. 6.56e+07. In the year 1990, what is the difference between the Aid flow (current US$) of Sub-Saharan Africa (all income levels) and Aid flow (current US$) of Venezuela?
Provide a short and direct response. 6.58e+07. In the year 1990, what is the difference between the Aid flow (current US$) of Afghanistan and Aid flow (current US$) of Indonesia?
Offer a very short reply. 1.26e+06. In the year 1990, what is the difference between the Aid flow (current US$) in Afghanistan and Aid flow (current US$) in Venezuela?
Ensure brevity in your answer.  1.37e+06. What is the ratio of the Aid flow (current US$) of Sub-Saharan Africa (all income levels) in 1983 to that in 1984?
Make the answer very short. 0.72. What is the ratio of the Aid flow (current US$) of Afghanistan in 1983 to that in 1984?
Give a very brief answer. 6.55. What is the ratio of the Aid flow (current US$) of Indonesia in 1983 to that in 1984?
Ensure brevity in your answer.  0.89. What is the ratio of the Aid flow (current US$) of Venezuela in 1983 to that in 1984?
Make the answer very short. 1.36. What is the ratio of the Aid flow (current US$) of Sub-Saharan Africa (all income levels) in 1983 to that in 1985?
Your answer should be compact. 0.63. What is the ratio of the Aid flow (current US$) of Afghanistan in 1983 to that in 1985?
Your response must be concise. 4.24. What is the ratio of the Aid flow (current US$) of Indonesia in 1983 to that in 1985?
Your answer should be very brief. 6.08. What is the ratio of the Aid flow (current US$) of Venezuela in 1983 to that in 1985?
Your answer should be very brief. 1.25. What is the ratio of the Aid flow (current US$) of Sub-Saharan Africa (all income levels) in 1983 to that in 1986?
Ensure brevity in your answer.  0.77. What is the ratio of the Aid flow (current US$) in Indonesia in 1983 to that in 1986?
Your answer should be compact. 15.68. What is the ratio of the Aid flow (current US$) of Venezuela in 1983 to that in 1986?
Your response must be concise. 0.88. What is the ratio of the Aid flow (current US$) in Sub-Saharan Africa (all income levels) in 1983 to that in 1987?
Ensure brevity in your answer.  0.32. What is the ratio of the Aid flow (current US$) in Afghanistan in 1983 to that in 1987?
Provide a short and direct response. 6.55. What is the ratio of the Aid flow (current US$) in Indonesia in 1983 to that in 1987?
Your answer should be compact. 5.42. What is the ratio of the Aid flow (current US$) of Sub-Saharan Africa (all income levels) in 1983 to that in 1988?
Your response must be concise. 0.25. What is the ratio of the Aid flow (current US$) in Afghanistan in 1983 to that in 1988?
Keep it short and to the point. 5.14. What is the ratio of the Aid flow (current US$) in Indonesia in 1983 to that in 1988?
Make the answer very short. 0.43. What is the ratio of the Aid flow (current US$) of Sub-Saharan Africa (all income levels) in 1983 to that in 1989?
Give a very brief answer. 0.24. What is the ratio of the Aid flow (current US$) in Afghanistan in 1983 to that in 1989?
Ensure brevity in your answer.  0.53. What is the ratio of the Aid flow (current US$) of Indonesia in 1983 to that in 1989?
Offer a terse response. 0.68. What is the ratio of the Aid flow (current US$) in Venezuela in 1983 to that in 1989?
Make the answer very short. 1.15. What is the ratio of the Aid flow (current US$) in Sub-Saharan Africa (all income levels) in 1983 to that in 1990?
Your answer should be compact. 0.15. What is the ratio of the Aid flow (current US$) in Afghanistan in 1983 to that in 1990?
Offer a very short reply. 0.48. What is the ratio of the Aid flow (current US$) in Indonesia in 1983 to that in 1990?
Your answer should be very brief. 12.96. What is the ratio of the Aid flow (current US$) in Sub-Saharan Africa (all income levels) in 1984 to that in 1985?
Ensure brevity in your answer.  0.88. What is the ratio of the Aid flow (current US$) in Afghanistan in 1984 to that in 1985?
Offer a very short reply. 0.65. What is the ratio of the Aid flow (current US$) in Indonesia in 1984 to that in 1985?
Your answer should be very brief. 6.8. What is the ratio of the Aid flow (current US$) of Sub-Saharan Africa (all income levels) in 1984 to that in 1986?
Provide a succinct answer. 1.07. What is the ratio of the Aid flow (current US$) in Afghanistan in 1984 to that in 1986?
Offer a terse response. 1.22. What is the ratio of the Aid flow (current US$) in Indonesia in 1984 to that in 1986?
Keep it short and to the point. 17.53. What is the ratio of the Aid flow (current US$) in Venezuela in 1984 to that in 1986?
Provide a short and direct response. 0.65. What is the ratio of the Aid flow (current US$) of Sub-Saharan Africa (all income levels) in 1984 to that in 1987?
Provide a succinct answer. 0.45. What is the ratio of the Aid flow (current US$) of Afghanistan in 1984 to that in 1987?
Ensure brevity in your answer.  1. What is the ratio of the Aid flow (current US$) of Indonesia in 1984 to that in 1987?
Provide a succinct answer. 6.05. What is the ratio of the Aid flow (current US$) in Venezuela in 1984 to that in 1987?
Your response must be concise. 3.67. What is the ratio of the Aid flow (current US$) of Sub-Saharan Africa (all income levels) in 1984 to that in 1988?
Provide a short and direct response. 0.35. What is the ratio of the Aid flow (current US$) of Afghanistan in 1984 to that in 1988?
Make the answer very short. 0.79. What is the ratio of the Aid flow (current US$) of Indonesia in 1984 to that in 1988?
Your answer should be compact. 0.49. What is the ratio of the Aid flow (current US$) in Sub-Saharan Africa (all income levels) in 1984 to that in 1989?
Your answer should be compact. 0.34. What is the ratio of the Aid flow (current US$) in Afghanistan in 1984 to that in 1989?
Provide a short and direct response. 0.08. What is the ratio of the Aid flow (current US$) in Indonesia in 1984 to that in 1989?
Ensure brevity in your answer.  0.76. What is the ratio of the Aid flow (current US$) in Venezuela in 1984 to that in 1989?
Offer a very short reply. 0.85. What is the ratio of the Aid flow (current US$) of Sub-Saharan Africa (all income levels) in 1984 to that in 1990?
Keep it short and to the point. 0.2. What is the ratio of the Aid flow (current US$) in Afghanistan in 1984 to that in 1990?
Your answer should be very brief. 0.07. What is the ratio of the Aid flow (current US$) in Indonesia in 1984 to that in 1990?
Keep it short and to the point. 14.48. What is the ratio of the Aid flow (current US$) in Venezuela in 1984 to that in 1990?
Your answer should be very brief. 0.92. What is the ratio of the Aid flow (current US$) of Sub-Saharan Africa (all income levels) in 1985 to that in 1986?
Offer a terse response. 1.21. What is the ratio of the Aid flow (current US$) in Afghanistan in 1985 to that in 1986?
Offer a terse response. 1.89. What is the ratio of the Aid flow (current US$) in Indonesia in 1985 to that in 1986?
Make the answer very short. 2.58. What is the ratio of the Aid flow (current US$) of Venezuela in 1985 to that in 1986?
Your answer should be very brief. 0.71. What is the ratio of the Aid flow (current US$) in Sub-Saharan Africa (all income levels) in 1985 to that in 1987?
Your answer should be very brief. 0.51. What is the ratio of the Aid flow (current US$) of Afghanistan in 1985 to that in 1987?
Your response must be concise. 1.55. What is the ratio of the Aid flow (current US$) in Indonesia in 1985 to that in 1987?
Keep it short and to the point. 0.89. What is the ratio of the Aid flow (current US$) in Venezuela in 1985 to that in 1987?
Ensure brevity in your answer.  4. What is the ratio of the Aid flow (current US$) in Sub-Saharan Africa (all income levels) in 1985 to that in 1988?
Offer a very short reply. 0.4. What is the ratio of the Aid flow (current US$) in Afghanistan in 1985 to that in 1988?
Ensure brevity in your answer.  1.21. What is the ratio of the Aid flow (current US$) of Indonesia in 1985 to that in 1988?
Offer a terse response. 0.07. What is the ratio of the Aid flow (current US$) in Sub-Saharan Africa (all income levels) in 1985 to that in 1989?
Your answer should be compact. 0.39. What is the ratio of the Aid flow (current US$) in Afghanistan in 1985 to that in 1989?
Your response must be concise. 0.13. What is the ratio of the Aid flow (current US$) in Indonesia in 1985 to that in 1989?
Your answer should be compact. 0.11. What is the ratio of the Aid flow (current US$) of Venezuela in 1985 to that in 1989?
Ensure brevity in your answer.  0.92. What is the ratio of the Aid flow (current US$) of Sub-Saharan Africa (all income levels) in 1985 to that in 1990?
Your answer should be compact. 0.23. What is the ratio of the Aid flow (current US$) in Afghanistan in 1985 to that in 1990?
Your answer should be very brief. 0.11. What is the ratio of the Aid flow (current US$) in Indonesia in 1985 to that in 1990?
Provide a short and direct response. 2.13. What is the ratio of the Aid flow (current US$) of Sub-Saharan Africa (all income levels) in 1986 to that in 1987?
Provide a succinct answer. 0.42. What is the ratio of the Aid flow (current US$) in Afghanistan in 1986 to that in 1987?
Provide a succinct answer. 0.82. What is the ratio of the Aid flow (current US$) of Indonesia in 1986 to that in 1987?
Your answer should be very brief. 0.35. What is the ratio of the Aid flow (current US$) in Venezuela in 1986 to that in 1987?
Provide a short and direct response. 5.67. What is the ratio of the Aid flow (current US$) of Sub-Saharan Africa (all income levels) in 1986 to that in 1988?
Ensure brevity in your answer.  0.33. What is the ratio of the Aid flow (current US$) in Afghanistan in 1986 to that in 1988?
Ensure brevity in your answer.  0.64. What is the ratio of the Aid flow (current US$) of Indonesia in 1986 to that in 1988?
Offer a terse response. 0.03. What is the ratio of the Aid flow (current US$) in Sub-Saharan Africa (all income levels) in 1986 to that in 1989?
Your response must be concise. 0.32. What is the ratio of the Aid flow (current US$) in Afghanistan in 1986 to that in 1989?
Your answer should be compact. 0.07. What is the ratio of the Aid flow (current US$) of Indonesia in 1986 to that in 1989?
Ensure brevity in your answer.  0.04. What is the ratio of the Aid flow (current US$) in Venezuela in 1986 to that in 1989?
Your answer should be compact. 1.31. What is the ratio of the Aid flow (current US$) of Sub-Saharan Africa (all income levels) in 1986 to that in 1990?
Offer a very short reply. 0.19. What is the ratio of the Aid flow (current US$) of Afghanistan in 1986 to that in 1990?
Provide a short and direct response. 0.06. What is the ratio of the Aid flow (current US$) of Indonesia in 1986 to that in 1990?
Give a very brief answer. 0.83. What is the ratio of the Aid flow (current US$) of Venezuela in 1986 to that in 1990?
Give a very brief answer. 1.42. What is the ratio of the Aid flow (current US$) in Sub-Saharan Africa (all income levels) in 1987 to that in 1988?
Provide a succinct answer. 0.77. What is the ratio of the Aid flow (current US$) of Afghanistan in 1987 to that in 1988?
Keep it short and to the point. 0.79. What is the ratio of the Aid flow (current US$) of Indonesia in 1987 to that in 1988?
Your answer should be compact. 0.08. What is the ratio of the Aid flow (current US$) of Sub-Saharan Africa (all income levels) in 1987 to that in 1989?
Your answer should be compact. 0.75. What is the ratio of the Aid flow (current US$) of Afghanistan in 1987 to that in 1989?
Offer a terse response. 0.08. What is the ratio of the Aid flow (current US$) of Indonesia in 1987 to that in 1989?
Your response must be concise. 0.12. What is the ratio of the Aid flow (current US$) in Venezuela in 1987 to that in 1989?
Offer a very short reply. 0.23. What is the ratio of the Aid flow (current US$) in Sub-Saharan Africa (all income levels) in 1987 to that in 1990?
Provide a short and direct response. 0.45. What is the ratio of the Aid flow (current US$) of Afghanistan in 1987 to that in 1990?
Provide a short and direct response. 0.07. What is the ratio of the Aid flow (current US$) in Indonesia in 1987 to that in 1990?
Provide a short and direct response. 2.39. What is the ratio of the Aid flow (current US$) in Sub-Saharan Africa (all income levels) in 1988 to that in 1989?
Provide a short and direct response. 0.97. What is the ratio of the Aid flow (current US$) of Afghanistan in 1988 to that in 1989?
Provide a short and direct response. 0.1. What is the ratio of the Aid flow (current US$) of Indonesia in 1988 to that in 1989?
Your answer should be very brief. 1.56. What is the ratio of the Aid flow (current US$) of Sub-Saharan Africa (all income levels) in 1988 to that in 1990?
Offer a terse response. 0.58. What is the ratio of the Aid flow (current US$) of Afghanistan in 1988 to that in 1990?
Make the answer very short. 0.09. What is the ratio of the Aid flow (current US$) of Indonesia in 1988 to that in 1990?
Give a very brief answer. 29.83. What is the ratio of the Aid flow (current US$) in Sub-Saharan Africa (all income levels) in 1989 to that in 1990?
Make the answer very short. 0.6. What is the ratio of the Aid flow (current US$) in Afghanistan in 1989 to that in 1990?
Provide a short and direct response. 0.91. What is the ratio of the Aid flow (current US$) of Indonesia in 1989 to that in 1990?
Give a very brief answer. 19.13. What is the ratio of the Aid flow (current US$) in Venezuela in 1989 to that in 1990?
Offer a terse response. 1.08. What is the difference between the highest and the second highest Aid flow (current US$) of Sub-Saharan Africa (all income levels)?
Offer a very short reply. 2.63e+07. What is the difference between the highest and the second highest Aid flow (current US$) of Indonesia?
Offer a terse response. 2.46e+06. What is the difference between the highest and the second highest Aid flow (current US$) in Venezuela?
Ensure brevity in your answer.  2.00e+04. What is the difference between the highest and the lowest Aid flow (current US$) in Sub-Saharan Africa (all income levels)?
Your response must be concise. 5.62e+07. What is the difference between the highest and the lowest Aid flow (current US$) of Afghanistan?
Your response must be concise. 1.40e+06. What is the difference between the highest and the lowest Aid flow (current US$) of Indonesia?
Your answer should be very brief. 6.67e+06. 